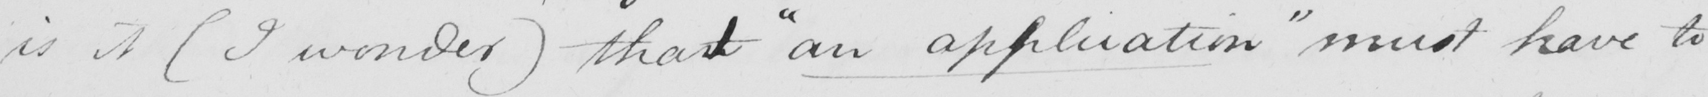What does this handwritten line say? is it  ( I wonder )  thant  " an application "  must have to 